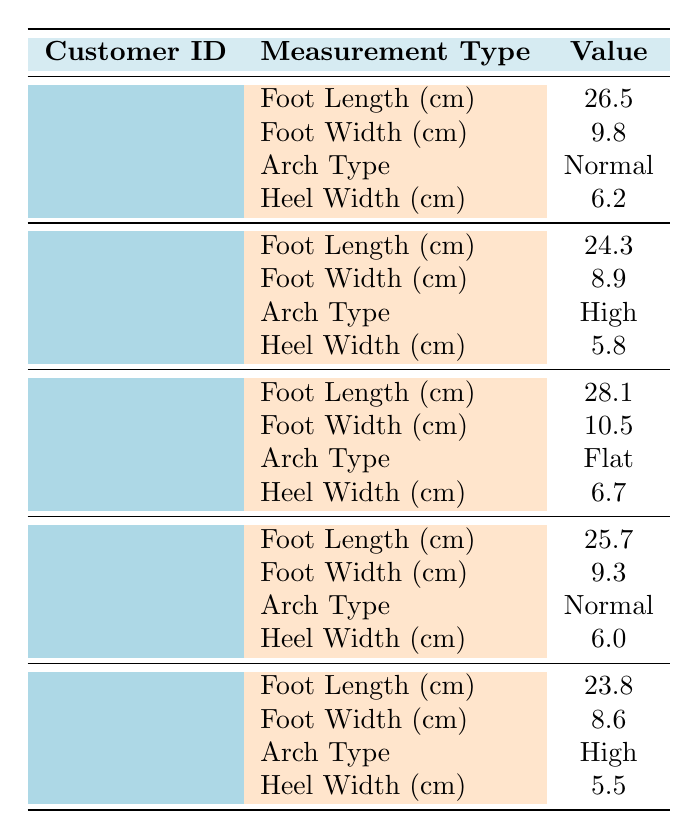What is the foot length of Customer ID C001? The table shows that for Customer ID C001, the measurement type "Foot Length (cm)" has a value of 26.5.
Answer: 26.5 cm What arch type does Customer ID C002 have? Referring to the data for Customer ID C002, the measurement type "Arch Type" indicates a value of "High."
Answer: High What is the average heel width for all customers? The heel widths for each customer are 6.2, 5.8, 6.7, 6.0, and 5.5 cm, which sum to 30.0 cm. Dividing by the number of customers (5), the average heel width is 30.0 / 5 = 6.0 cm.
Answer: 6.0 cm Is the arch type for Customer ID C003 flat? Looking at the data for Customer ID C003, the arch type entry states "Flat," confirming the statement as true.
Answer: Yes What is the difference between the foot length of Customer ID C003 and C005? The foot length for Customer ID C003 is 28.1 cm and for C005 it is 23.8 cm. The difference is 28.1 - 23.8 = 4.3 cm.
Answer: 4.3 cm How many customers have a normal arch type? By examining the entries, C001 and C004 both list "Normal" as their arch type. Thus, there are 2 customers with a normal arch type.
Answer: 2 Which customer has the widest foot? The foot widths given are 9.8 cm (C001), 8.9 cm (C002), 10.5 cm (C003), 9.3 cm (C004), and 8.6 cm (C005). The widest measurement is 10.5 cm for Customer ID C003.
Answer: C003 If we only consider high arch types, what is the average foot width? Customers with a high arch type are C002 and C005, whose foot widths are 8.9 cm and 8.6 cm. The average width is (8.9 + 8.6) / 2 = 8.75 cm.
Answer: 8.75 cm What is the sum of foot lengths for all customers? The foot lengths are 26.5 (C001), 24.3 (C002), 28.1 (C003), 25.7 (C004), and 23.8 (C005). Summing these values gives 26.5 + 24.3 + 28.1 + 25.7 + 23.8 = 128.4 cm.
Answer: 128.4 cm Does Customer ID C005 have a foot length greater than 25 cm? The measurement for Customer ID C005's foot length is 23.8 cm, which is less than 25 cm, confirming the statement as false.
Answer: No 